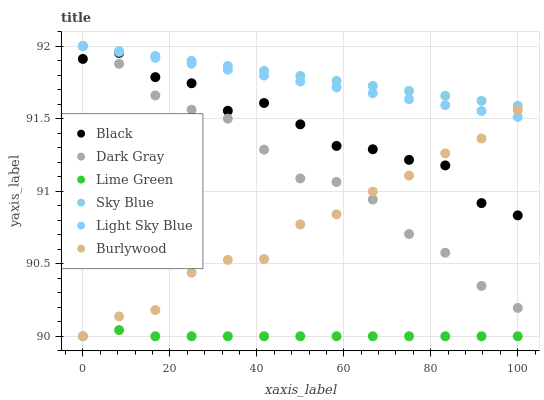Does Lime Green have the minimum area under the curve?
Answer yes or no. Yes. Does Sky Blue have the maximum area under the curve?
Answer yes or no. Yes. Does Dark Gray have the minimum area under the curve?
Answer yes or no. No. Does Dark Gray have the maximum area under the curve?
Answer yes or no. No. Is Light Sky Blue the smoothest?
Answer yes or no. Yes. Is Black the roughest?
Answer yes or no. Yes. Is Dark Gray the smoothest?
Answer yes or no. No. Is Dark Gray the roughest?
Answer yes or no. No. Does Burlywood have the lowest value?
Answer yes or no. Yes. Does Dark Gray have the lowest value?
Answer yes or no. No. Does Sky Blue have the highest value?
Answer yes or no. Yes. Does Black have the highest value?
Answer yes or no. No. Is Lime Green less than Black?
Answer yes or no. Yes. Is Light Sky Blue greater than Black?
Answer yes or no. Yes. Does Light Sky Blue intersect Dark Gray?
Answer yes or no. Yes. Is Light Sky Blue less than Dark Gray?
Answer yes or no. No. Is Light Sky Blue greater than Dark Gray?
Answer yes or no. No. Does Lime Green intersect Black?
Answer yes or no. No. 